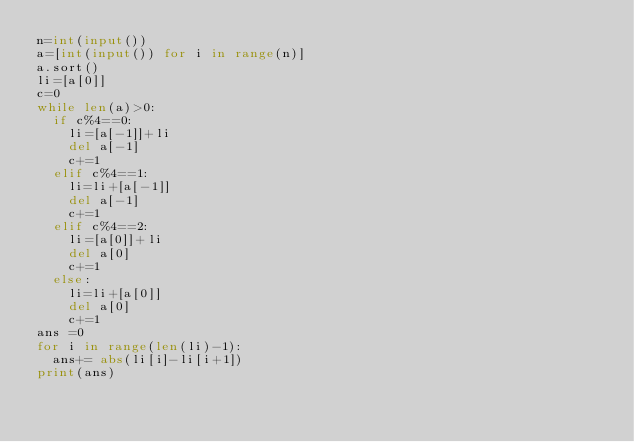Convert code to text. <code><loc_0><loc_0><loc_500><loc_500><_Python_>n=int(input())
a=[int(input()) for i in range(n)]
a.sort()
li=[a[0]]
c=0
while len(a)>0:
  if c%4==0:
    li=[a[-1]]+li
    del a[-1]
    c+=1
  elif c%4==1:
    li=li+[a[-1]]
    del a[-1]
    c+=1
  elif c%4==2:
    li=[a[0]]+li
    del a[0]
    c+=1
  else:
    li=li+[a[0]]
    del a[0]
    c+=1
ans =0
for i in range(len(li)-1):
  ans+= abs(li[i]-li[i+1])
print(ans)</code> 